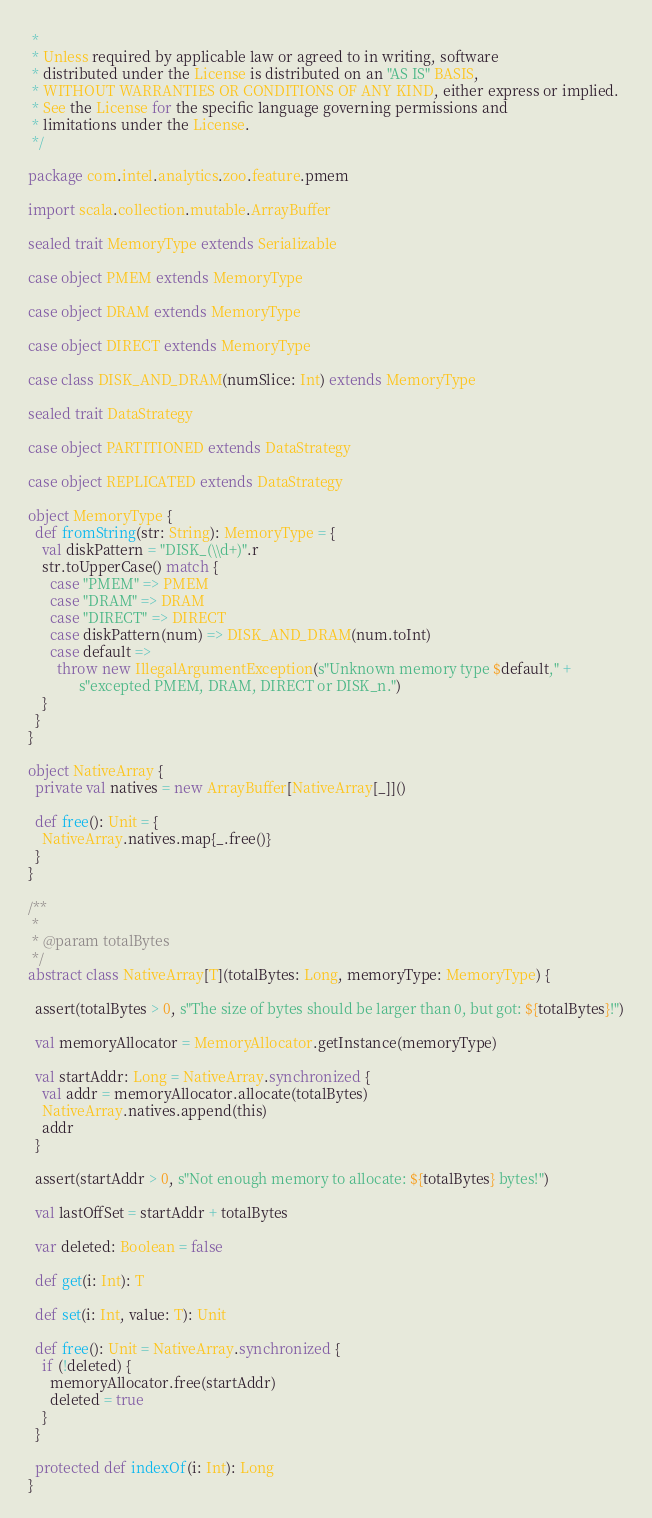Convert code to text. <code><loc_0><loc_0><loc_500><loc_500><_Scala_> *
 * Unless required by applicable law or agreed to in writing, software
 * distributed under the License is distributed on an "AS IS" BASIS,
 * WITHOUT WARRANTIES OR CONDITIONS OF ANY KIND, either express or implied.
 * See the License for the specific language governing permissions and
 * limitations under the License.
 */

package com.intel.analytics.zoo.feature.pmem

import scala.collection.mutable.ArrayBuffer

sealed trait MemoryType extends Serializable

case object PMEM extends MemoryType

case object DRAM extends MemoryType

case object DIRECT extends MemoryType

case class DISK_AND_DRAM(numSlice: Int) extends MemoryType

sealed trait DataStrategy

case object PARTITIONED extends DataStrategy

case object REPLICATED extends DataStrategy

object MemoryType {
  def fromString(str: String): MemoryType = {
    val diskPattern = "DISK_(\\d+)".r
    str.toUpperCase() match {
      case "PMEM" => PMEM
      case "DRAM" => DRAM
      case "DIRECT" => DIRECT
      case diskPattern(num) => DISK_AND_DRAM(num.toInt)
      case default =>
        throw new IllegalArgumentException(s"Unknown memory type $default," +
              s"excepted PMEM, DRAM, DIRECT or DISK_n.")
    }
  }
}

object NativeArray {
  private val natives = new ArrayBuffer[NativeArray[_]]()

  def free(): Unit = {
    NativeArray.natives.map{_.free()}
  }
}

/**
 *
 * @param totalBytes
 */
abstract class NativeArray[T](totalBytes: Long, memoryType: MemoryType) {

  assert(totalBytes > 0, s"The size of bytes should be larger than 0, but got: ${totalBytes}!")

  val memoryAllocator = MemoryAllocator.getInstance(memoryType)

  val startAddr: Long = NativeArray.synchronized {
    val addr = memoryAllocator.allocate(totalBytes)
    NativeArray.natives.append(this)
    addr
  }

  assert(startAddr > 0, s"Not enough memory to allocate: ${totalBytes} bytes!")

  val lastOffSet = startAddr + totalBytes

  var deleted: Boolean = false

  def get(i: Int): T

  def set(i: Int, value: T): Unit

  def free(): Unit = NativeArray.synchronized {
    if (!deleted) {
      memoryAllocator.free(startAddr)
      deleted = true
    }
  }

  protected def indexOf(i: Int): Long
}


</code> 